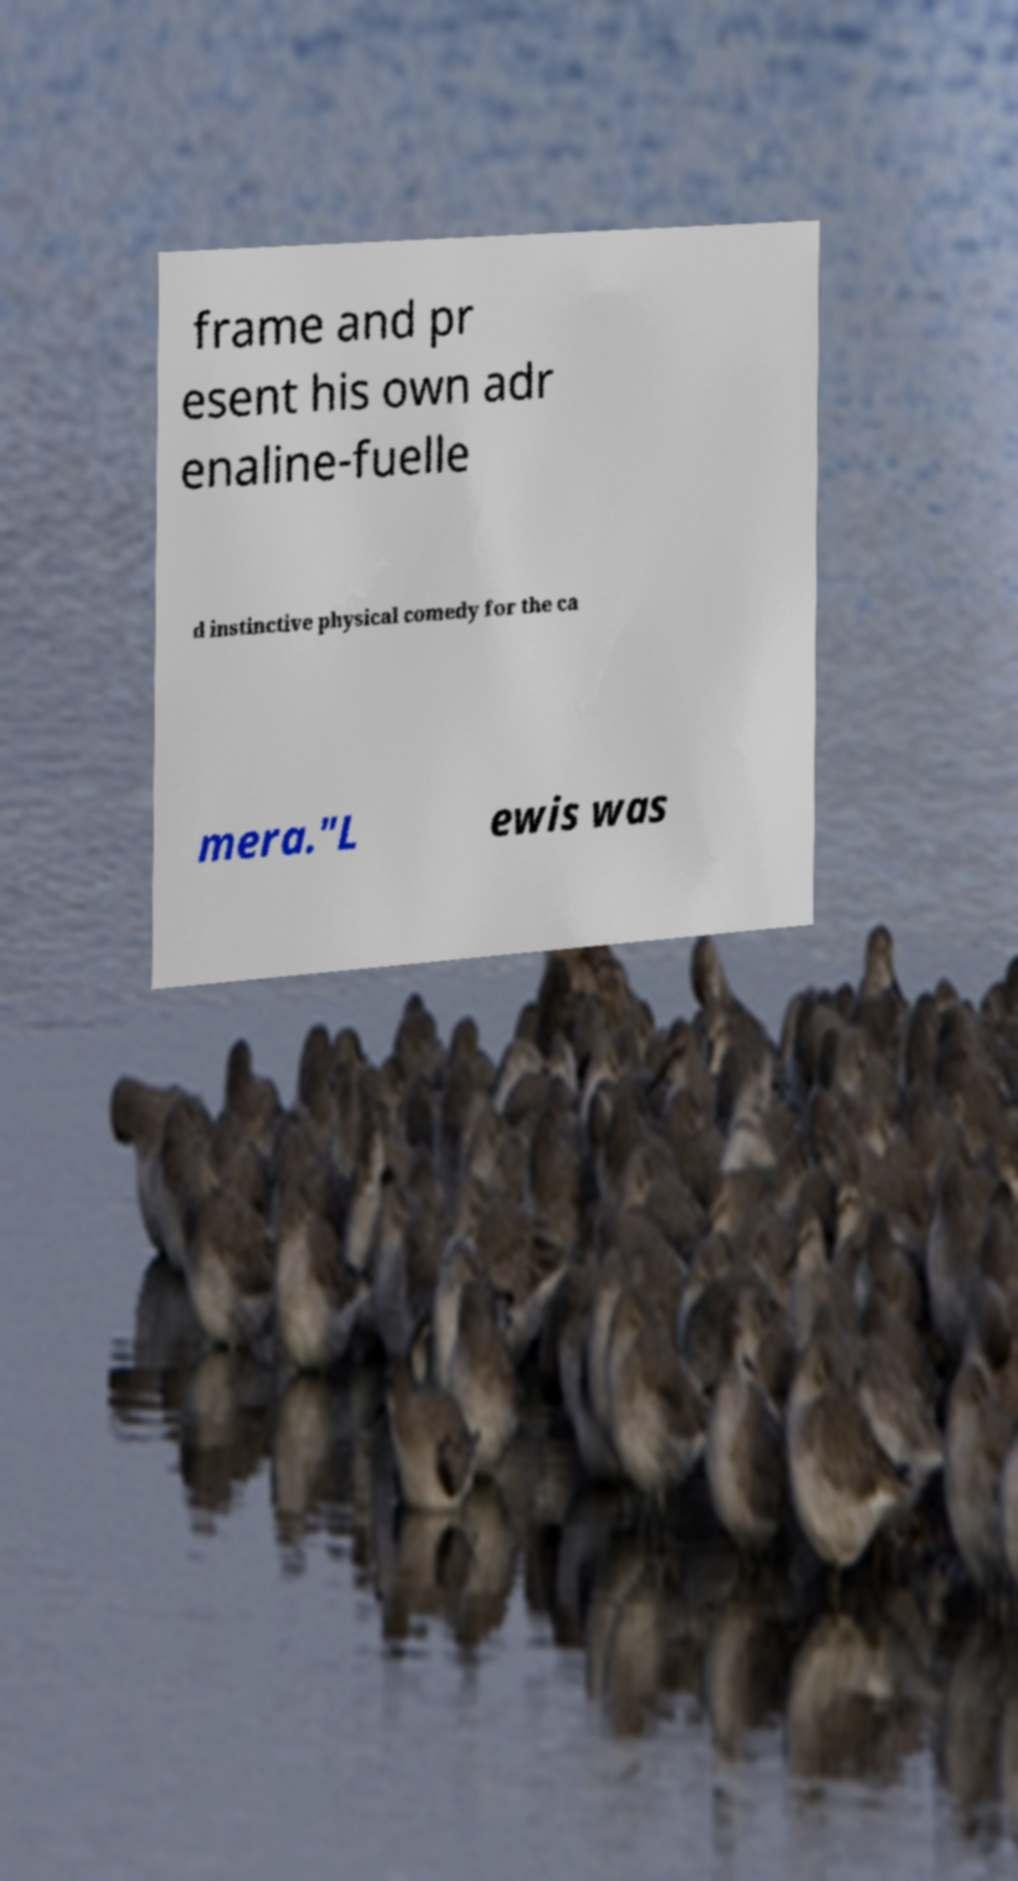Can you accurately transcribe the text from the provided image for me? frame and pr esent his own adr enaline-fuelle d instinctive physical comedy for the ca mera."L ewis was 